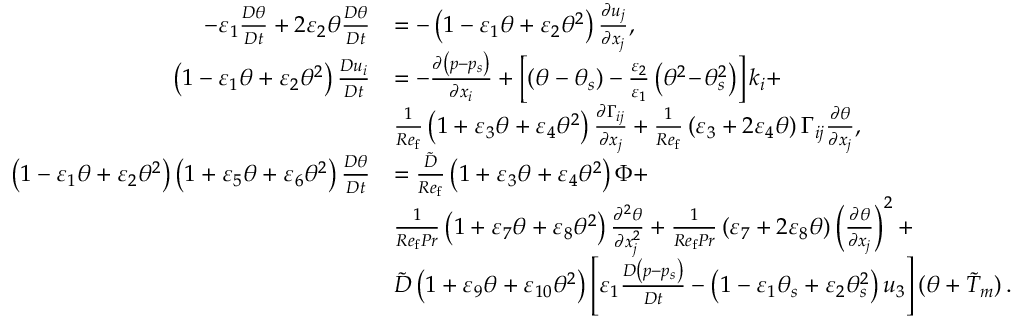<formula> <loc_0><loc_0><loc_500><loc_500>\begin{array} { r l } { - \varepsilon _ { 1 } \frac { D \theta } { D t } + 2 \varepsilon _ { 2 } \theta \frac { D \theta } { D t } } & { = - \left ( 1 - \varepsilon _ { 1 } \theta + \varepsilon _ { 2 } \theta ^ { 2 } \right ) \frac { \partial u _ { j } } { \partial x _ { j } } , } \\ { \left ( 1 - \varepsilon _ { 1 } \theta + \varepsilon _ { 2 } \theta ^ { 2 } \right ) \frac { D u _ { i } } { D t } } & { = - \frac { \partial \left ( p - p _ { s } \right ) } { \partial x _ { i } } + \left [ \left ( \theta - \theta _ { s } \right ) - \frac { \varepsilon _ { 2 } } { \varepsilon _ { 1 } } \left ( \theta ^ { 2 } \, - \, \theta _ { s } ^ { 2 } \right ) \right ] k _ { i } + } \\ & { \frac { 1 } { R e _ { f } } \left ( 1 + \varepsilon _ { 3 } \theta + \varepsilon _ { 4 } \theta ^ { 2 } \right ) \frac { \partial \Gamma _ { i j } } { \partial x _ { j } } + \frac { 1 } { R e _ { f } } \left ( \varepsilon _ { 3 } + 2 \varepsilon _ { 4 } \theta \right ) \Gamma _ { i j } \frac { \partial \theta } { \partial x _ { j } } , } \\ { \left ( 1 - \varepsilon _ { 1 } \theta + \varepsilon _ { 2 } \theta ^ { 2 } \right ) \left ( 1 + \varepsilon _ { 5 } \theta + \varepsilon _ { 6 } \theta ^ { 2 } \right ) \frac { D \theta } { D t } } & { = \frac { \tilde { D } } { R e _ { f } } \left ( 1 + \varepsilon _ { 3 } \theta + \varepsilon _ { 4 } \theta ^ { 2 } \right ) \Phi + } \\ & { \frac { 1 } { R e _ { f } P r } \left ( 1 + \varepsilon _ { 7 } \theta + \varepsilon _ { 8 } \theta ^ { 2 } \right ) \frac { \partial ^ { 2 } \theta } { \partial x _ { j } ^ { 2 } } + \frac { 1 } { R e _ { f } P r } \left ( \varepsilon _ { 7 } + 2 \varepsilon _ { 8 } \theta \right ) \left ( \frac { \partial \theta } { \partial x _ { j } } \right ) ^ { 2 } + } \\ & { \tilde { D } \left ( 1 + \varepsilon _ { 9 } \theta + \varepsilon _ { 1 0 } \theta ^ { 2 } \right ) \left [ \varepsilon _ { 1 } \frac { D \left ( p - p _ { s } \right ) } { D t } - \left ( 1 - \varepsilon _ { 1 } \theta _ { s } + \varepsilon _ { 2 } \theta _ { s } ^ { 2 } \right ) u _ { 3 } \right ] ( \theta + \tilde { T } _ { m } ) \, . } \end{array}</formula> 